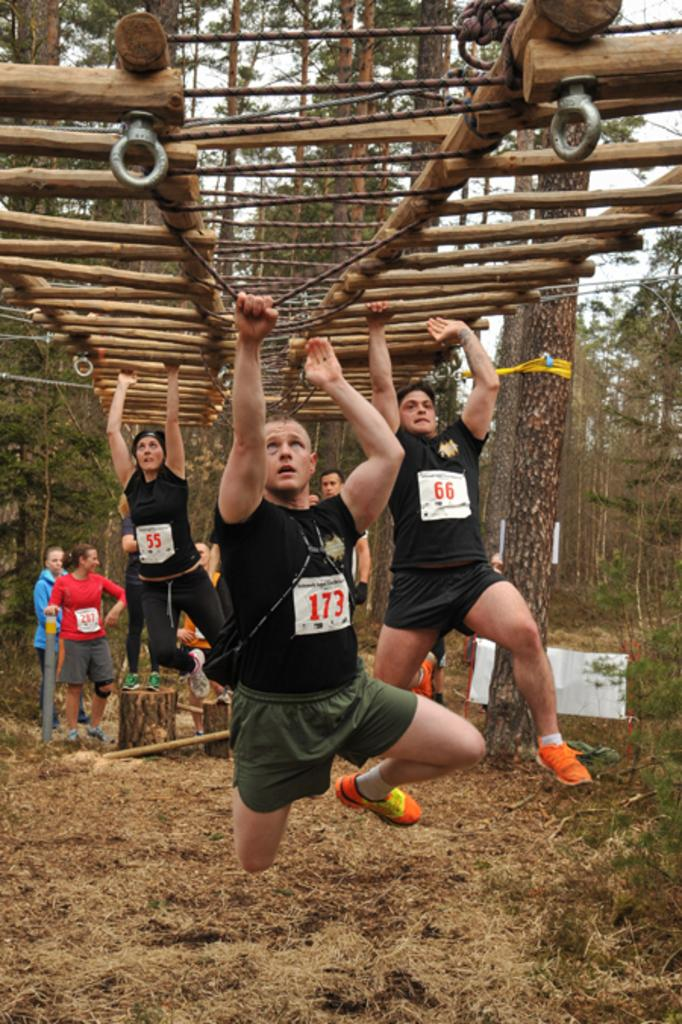Provide a one-sentence caption for the provided image. Number 173 appears to be in the lead of this race. 